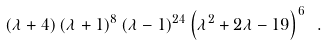<formula> <loc_0><loc_0><loc_500><loc_500>\left ( \lambda + 4 \right ) \left ( \lambda + 1 \right ) ^ { 8 } \left ( \lambda - 1 \right ) ^ { 2 4 } \left ( \lambda ^ { 2 } + 2 \lambda - 1 9 \right ) ^ { 6 } \ .</formula> 